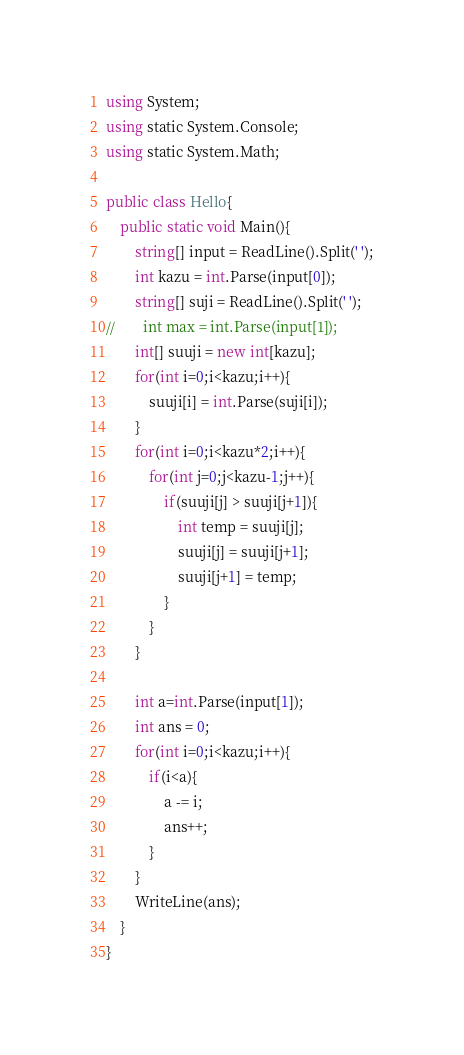<code> <loc_0><loc_0><loc_500><loc_500><_C#_>using System;
using static System.Console;
using static System.Math;

public class Hello{
    public static void Main(){
        string[] input = ReadLine().Split(' ');
        int kazu = int.Parse(input[0]);
        string[] suji = ReadLine().Split(' ');
//        int max = int.Parse(input[1]);
        int[] suuji = new int[kazu];
        for(int i=0;i<kazu;i++){
            suuji[i] = int.Parse(suji[i]);
        }
        for(int i=0;i<kazu*2;i++){
            for(int j=0;j<kazu-1;j++){
                if(suuji[j] > suuji[j+1]){
                    int temp = suuji[j];
                    suuji[j] = suuji[j+1];
                    suuji[j+1] = temp;
                }
            }
        }
        
        int a=int.Parse(input[1]);
        int ans = 0;
        for(int i=0;i<kazu;i++){
            if(i<a){
                a -= i;
                ans++;
            }
        }
        WriteLine(ans);
    }
}</code> 